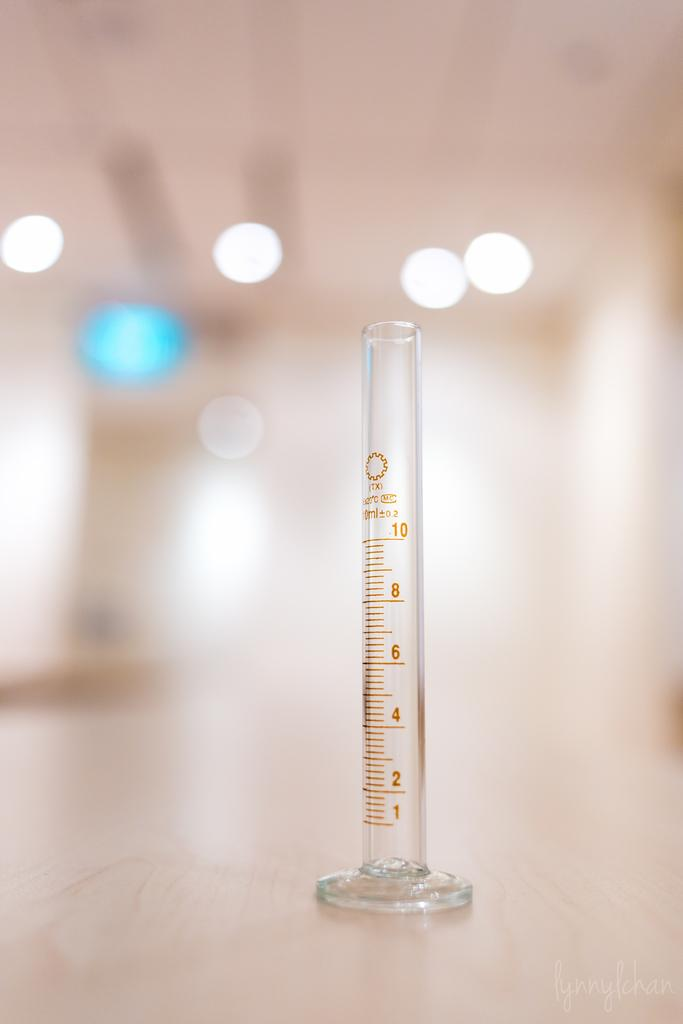<image>
Summarize the visual content of the image. a clear test tube measuring from 1 to 10 